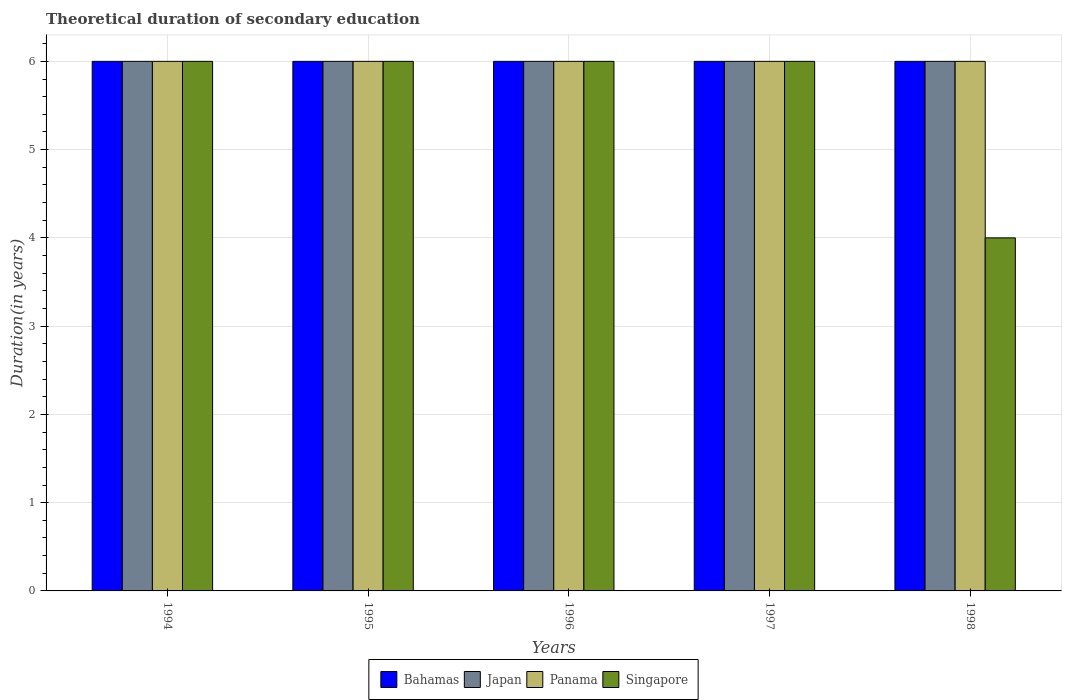How many different coloured bars are there?
Your response must be concise. 4. How many groups of bars are there?
Ensure brevity in your answer.  5. Are the number of bars on each tick of the X-axis equal?
Provide a short and direct response. Yes. How many bars are there on the 4th tick from the right?
Provide a short and direct response. 4. In how many cases, is the number of bars for a given year not equal to the number of legend labels?
Provide a short and direct response. 0. Across all years, what is the minimum total theoretical duration of secondary education in Singapore?
Offer a very short reply. 4. In which year was the total theoretical duration of secondary education in Panama minimum?
Provide a succinct answer. 1994. What is the total total theoretical duration of secondary education in Bahamas in the graph?
Your answer should be very brief. 30. What is the difference between the total theoretical duration of secondary education in Singapore in 1994 and that in 1995?
Offer a terse response. 0. What is the average total theoretical duration of secondary education in Singapore per year?
Provide a short and direct response. 5.6. What is the ratio of the total theoretical duration of secondary education in Bahamas in 1996 to that in 1997?
Your answer should be compact. 1. Is the total theoretical duration of secondary education in Bahamas in 1995 less than that in 1997?
Your answer should be very brief. No. What is the difference between the highest and the second highest total theoretical duration of secondary education in Japan?
Offer a very short reply. 0. What is the difference between the highest and the lowest total theoretical duration of secondary education in Singapore?
Provide a succinct answer. 2. Is the sum of the total theoretical duration of secondary education in Japan in 1994 and 1995 greater than the maximum total theoretical duration of secondary education in Panama across all years?
Your response must be concise. Yes. What does the 1st bar from the left in 1996 represents?
Offer a very short reply. Bahamas. Is it the case that in every year, the sum of the total theoretical duration of secondary education in Panama and total theoretical duration of secondary education in Singapore is greater than the total theoretical duration of secondary education in Bahamas?
Your answer should be very brief. Yes. Does the graph contain grids?
Make the answer very short. Yes. Where does the legend appear in the graph?
Your answer should be very brief. Bottom center. How many legend labels are there?
Offer a very short reply. 4. What is the title of the graph?
Give a very brief answer. Theoretical duration of secondary education. Does "Malawi" appear as one of the legend labels in the graph?
Give a very brief answer. No. What is the label or title of the Y-axis?
Your response must be concise. Duration(in years). What is the Duration(in years) in Bahamas in 1995?
Offer a terse response. 6. What is the Duration(in years) of Singapore in 1995?
Keep it short and to the point. 6. What is the Duration(in years) of Bahamas in 1996?
Offer a very short reply. 6. What is the Duration(in years) of Japan in 1996?
Your response must be concise. 6. What is the Duration(in years) in Panama in 1997?
Give a very brief answer. 6. What is the Duration(in years) of Singapore in 1997?
Your response must be concise. 6. What is the Duration(in years) in Bahamas in 1998?
Make the answer very short. 6. What is the Duration(in years) in Japan in 1998?
Keep it short and to the point. 6. Across all years, what is the maximum Duration(in years) of Bahamas?
Your response must be concise. 6. Across all years, what is the minimum Duration(in years) in Bahamas?
Give a very brief answer. 6. Across all years, what is the minimum Duration(in years) of Japan?
Offer a very short reply. 6. Across all years, what is the minimum Duration(in years) of Singapore?
Provide a succinct answer. 4. What is the difference between the Duration(in years) in Bahamas in 1994 and that in 1995?
Provide a short and direct response. 0. What is the difference between the Duration(in years) in Japan in 1994 and that in 1995?
Offer a very short reply. 0. What is the difference between the Duration(in years) of Panama in 1994 and that in 1995?
Your answer should be compact. 0. What is the difference between the Duration(in years) in Singapore in 1994 and that in 1995?
Make the answer very short. 0. What is the difference between the Duration(in years) of Japan in 1994 and that in 1996?
Provide a succinct answer. 0. What is the difference between the Duration(in years) of Panama in 1994 and that in 1996?
Your response must be concise. 0. What is the difference between the Duration(in years) of Bahamas in 1994 and that in 1998?
Offer a terse response. 0. What is the difference between the Duration(in years) in Singapore in 1994 and that in 1998?
Your answer should be very brief. 2. What is the difference between the Duration(in years) of Bahamas in 1995 and that in 1996?
Provide a succinct answer. 0. What is the difference between the Duration(in years) in Panama in 1995 and that in 1996?
Your response must be concise. 0. What is the difference between the Duration(in years) of Japan in 1995 and that in 1997?
Your answer should be compact. 0. What is the difference between the Duration(in years) in Japan in 1995 and that in 1998?
Offer a very short reply. 0. What is the difference between the Duration(in years) of Singapore in 1995 and that in 1998?
Your answer should be compact. 2. What is the difference between the Duration(in years) in Japan in 1996 and that in 1997?
Your response must be concise. 0. What is the difference between the Duration(in years) of Panama in 1996 and that in 1997?
Provide a short and direct response. 0. What is the difference between the Duration(in years) of Singapore in 1996 and that in 1997?
Give a very brief answer. 0. What is the difference between the Duration(in years) of Japan in 1996 and that in 1998?
Provide a short and direct response. 0. What is the difference between the Duration(in years) in Japan in 1997 and that in 1998?
Your answer should be very brief. 0. What is the difference between the Duration(in years) of Panama in 1997 and that in 1998?
Offer a very short reply. 0. What is the difference between the Duration(in years) in Bahamas in 1994 and the Duration(in years) in Panama in 1995?
Ensure brevity in your answer.  0. What is the difference between the Duration(in years) of Bahamas in 1994 and the Duration(in years) of Singapore in 1995?
Give a very brief answer. 0. What is the difference between the Duration(in years) of Japan in 1994 and the Duration(in years) of Panama in 1996?
Keep it short and to the point. 0. What is the difference between the Duration(in years) in Japan in 1994 and the Duration(in years) in Singapore in 1996?
Provide a succinct answer. 0. What is the difference between the Duration(in years) in Panama in 1994 and the Duration(in years) in Singapore in 1996?
Give a very brief answer. 0. What is the difference between the Duration(in years) of Bahamas in 1994 and the Duration(in years) of Japan in 1997?
Give a very brief answer. 0. What is the difference between the Duration(in years) of Bahamas in 1994 and the Duration(in years) of Singapore in 1997?
Your answer should be very brief. 0. What is the difference between the Duration(in years) in Japan in 1994 and the Duration(in years) in Singapore in 1997?
Your answer should be compact. 0. What is the difference between the Duration(in years) of Panama in 1994 and the Duration(in years) of Singapore in 1997?
Your response must be concise. 0. What is the difference between the Duration(in years) of Bahamas in 1994 and the Duration(in years) of Panama in 1998?
Offer a very short reply. 0. What is the difference between the Duration(in years) in Bahamas in 1994 and the Duration(in years) in Singapore in 1998?
Your answer should be very brief. 2. What is the difference between the Duration(in years) in Panama in 1994 and the Duration(in years) in Singapore in 1998?
Your answer should be very brief. 2. What is the difference between the Duration(in years) of Bahamas in 1995 and the Duration(in years) of Singapore in 1996?
Your answer should be very brief. 0. What is the difference between the Duration(in years) of Japan in 1995 and the Duration(in years) of Panama in 1996?
Ensure brevity in your answer.  0. What is the difference between the Duration(in years) of Japan in 1995 and the Duration(in years) of Singapore in 1996?
Your answer should be very brief. 0. What is the difference between the Duration(in years) of Panama in 1995 and the Duration(in years) of Singapore in 1996?
Keep it short and to the point. 0. What is the difference between the Duration(in years) of Bahamas in 1995 and the Duration(in years) of Japan in 1997?
Make the answer very short. 0. What is the difference between the Duration(in years) of Japan in 1995 and the Duration(in years) of Panama in 1997?
Offer a very short reply. 0. What is the difference between the Duration(in years) in Japan in 1995 and the Duration(in years) in Singapore in 1997?
Ensure brevity in your answer.  0. What is the difference between the Duration(in years) in Bahamas in 1995 and the Duration(in years) in Panama in 1998?
Provide a succinct answer. 0. What is the difference between the Duration(in years) of Bahamas in 1995 and the Duration(in years) of Singapore in 1998?
Give a very brief answer. 2. What is the difference between the Duration(in years) of Japan in 1995 and the Duration(in years) of Panama in 1998?
Your answer should be compact. 0. What is the difference between the Duration(in years) of Japan in 1995 and the Duration(in years) of Singapore in 1998?
Offer a very short reply. 2. What is the difference between the Duration(in years) of Bahamas in 1996 and the Duration(in years) of Japan in 1997?
Provide a short and direct response. 0. What is the difference between the Duration(in years) in Panama in 1996 and the Duration(in years) in Singapore in 1997?
Offer a terse response. 0. What is the difference between the Duration(in years) of Japan in 1996 and the Duration(in years) of Panama in 1998?
Provide a succinct answer. 0. What is the difference between the Duration(in years) in Japan in 1996 and the Duration(in years) in Singapore in 1998?
Your response must be concise. 2. What is the difference between the Duration(in years) in Panama in 1996 and the Duration(in years) in Singapore in 1998?
Your response must be concise. 2. What is the difference between the Duration(in years) in Japan in 1997 and the Duration(in years) in Singapore in 1998?
Your response must be concise. 2. What is the difference between the Duration(in years) of Panama in 1997 and the Duration(in years) of Singapore in 1998?
Offer a very short reply. 2. What is the average Duration(in years) of Bahamas per year?
Provide a succinct answer. 6. What is the average Duration(in years) of Japan per year?
Your answer should be compact. 6. What is the average Duration(in years) of Singapore per year?
Offer a terse response. 5.6. In the year 1994, what is the difference between the Duration(in years) in Bahamas and Duration(in years) in Japan?
Provide a succinct answer. 0. In the year 1994, what is the difference between the Duration(in years) of Bahamas and Duration(in years) of Panama?
Your response must be concise. 0. In the year 1994, what is the difference between the Duration(in years) of Japan and Duration(in years) of Singapore?
Your response must be concise. 0. In the year 1995, what is the difference between the Duration(in years) in Bahamas and Duration(in years) in Japan?
Give a very brief answer. 0. In the year 1995, what is the difference between the Duration(in years) of Japan and Duration(in years) of Panama?
Your answer should be very brief. 0. In the year 1996, what is the difference between the Duration(in years) of Japan and Duration(in years) of Panama?
Your answer should be compact. 0. In the year 1996, what is the difference between the Duration(in years) in Japan and Duration(in years) in Singapore?
Keep it short and to the point. 0. In the year 1996, what is the difference between the Duration(in years) in Panama and Duration(in years) in Singapore?
Your answer should be compact. 0. In the year 1997, what is the difference between the Duration(in years) of Bahamas and Duration(in years) of Panama?
Your answer should be very brief. 0. In the year 1997, what is the difference between the Duration(in years) of Bahamas and Duration(in years) of Singapore?
Provide a succinct answer. 0. In the year 1997, what is the difference between the Duration(in years) in Japan and Duration(in years) in Panama?
Ensure brevity in your answer.  0. In the year 1998, what is the difference between the Duration(in years) in Japan and Duration(in years) in Panama?
Offer a very short reply. 0. In the year 1998, what is the difference between the Duration(in years) in Japan and Duration(in years) in Singapore?
Your answer should be compact. 2. What is the ratio of the Duration(in years) in Bahamas in 1994 to that in 1995?
Make the answer very short. 1. What is the ratio of the Duration(in years) in Panama in 1994 to that in 1996?
Ensure brevity in your answer.  1. What is the ratio of the Duration(in years) in Japan in 1994 to that in 1997?
Your answer should be very brief. 1. What is the ratio of the Duration(in years) in Panama in 1994 to that in 1997?
Your response must be concise. 1. What is the ratio of the Duration(in years) in Bahamas in 1994 to that in 1998?
Give a very brief answer. 1. What is the ratio of the Duration(in years) of Japan in 1995 to that in 1996?
Ensure brevity in your answer.  1. What is the ratio of the Duration(in years) in Bahamas in 1995 to that in 1997?
Your answer should be compact. 1. What is the ratio of the Duration(in years) in Japan in 1995 to that in 1997?
Make the answer very short. 1. What is the ratio of the Duration(in years) of Bahamas in 1995 to that in 1998?
Make the answer very short. 1. What is the ratio of the Duration(in years) of Panama in 1995 to that in 1998?
Your answer should be compact. 1. What is the ratio of the Duration(in years) of Bahamas in 1996 to that in 1997?
Provide a short and direct response. 1. What is the ratio of the Duration(in years) in Panama in 1996 to that in 1997?
Give a very brief answer. 1. What is the ratio of the Duration(in years) in Bahamas in 1996 to that in 1998?
Ensure brevity in your answer.  1. What is the ratio of the Duration(in years) in Japan in 1996 to that in 1998?
Your answer should be compact. 1. What is the ratio of the Duration(in years) in Panama in 1996 to that in 1998?
Your response must be concise. 1. What is the ratio of the Duration(in years) in Singapore in 1996 to that in 1998?
Give a very brief answer. 1.5. What is the ratio of the Duration(in years) in Panama in 1997 to that in 1998?
Your response must be concise. 1. What is the ratio of the Duration(in years) of Singapore in 1997 to that in 1998?
Your answer should be compact. 1.5. What is the difference between the highest and the lowest Duration(in years) of Bahamas?
Give a very brief answer. 0. What is the difference between the highest and the lowest Duration(in years) of Japan?
Provide a short and direct response. 0. What is the difference between the highest and the lowest Duration(in years) of Panama?
Provide a short and direct response. 0. 